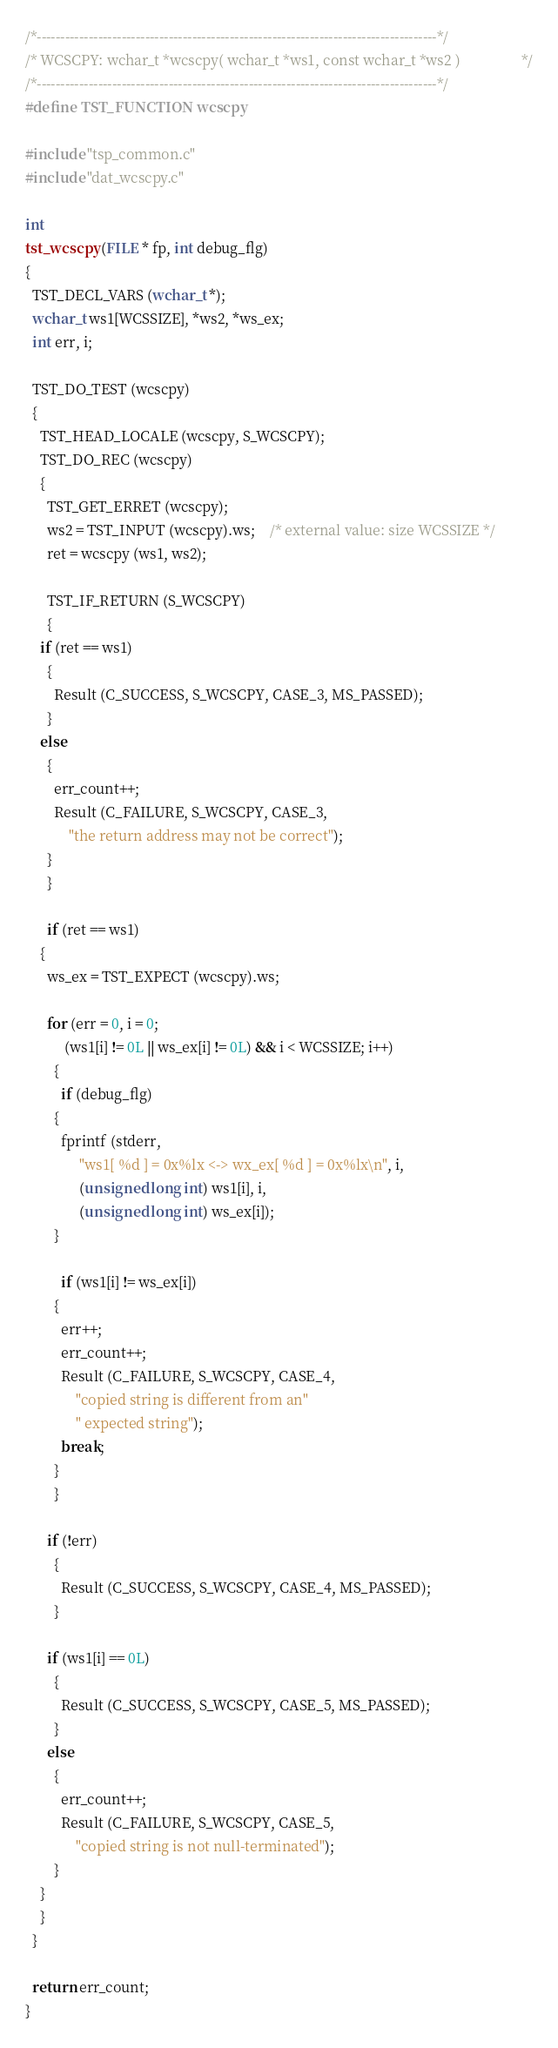<code> <loc_0><loc_0><loc_500><loc_500><_C_>/*-------------------------------------------------------------------------------------*/
/* WCSCPY: wchar_t *wcscpy( wchar_t *ws1, const wchar_t *ws2 )			       */
/*-------------------------------------------------------------------------------------*/
#define TST_FUNCTION wcscpy

#include "tsp_common.c"
#include "dat_wcscpy.c"

int
tst_wcscpy (FILE * fp, int debug_flg)
{
  TST_DECL_VARS (wchar_t *);
  wchar_t ws1[WCSSIZE], *ws2, *ws_ex;
  int err, i;

  TST_DO_TEST (wcscpy)
  {
    TST_HEAD_LOCALE (wcscpy, S_WCSCPY);
    TST_DO_REC (wcscpy)
    {
      TST_GET_ERRET (wcscpy);
      ws2 = TST_INPUT (wcscpy).ws;	/* external value: size WCSSIZE */
      ret = wcscpy (ws1, ws2);

      TST_IF_RETURN (S_WCSCPY)
      {
	if (ret == ws1)
	  {
	    Result (C_SUCCESS, S_WCSCPY, CASE_3, MS_PASSED);
	  }
	else
	  {
	    err_count++;
	    Result (C_FAILURE, S_WCSCPY, CASE_3,
		    "the return address may not be correct");
	  }
      }

      if (ret == ws1)
	{
	  ws_ex = TST_EXPECT (wcscpy).ws;

	  for (err = 0, i = 0;
	       (ws1[i] != 0L || ws_ex[i] != 0L) && i < WCSSIZE; i++)
	    {
	      if (debug_flg)
		{
		  fprintf (stderr,
			   "ws1[ %d ] = 0x%lx <-> wx_ex[ %d ] = 0x%lx\n", i,
			   (unsigned long int) ws1[i], i,
			   (unsigned long int) ws_ex[i]);
		}

	      if (ws1[i] != ws_ex[i])
		{
		  err++;
		  err_count++;
		  Result (C_FAILURE, S_WCSCPY, CASE_4,
			  "copied string is different from an"
			  " expected string");
		  break;
		}
	    }

	  if (!err)
	    {
	      Result (C_SUCCESS, S_WCSCPY, CASE_4, MS_PASSED);
	    }

	  if (ws1[i] == 0L)
	    {
	      Result (C_SUCCESS, S_WCSCPY, CASE_5, MS_PASSED);
	    }
	  else
	    {
	      err_count++;
	      Result (C_FAILURE, S_WCSCPY, CASE_5,
		      "copied string is not null-terminated");
	    }
	}
    }
  }

  return err_count;
}
</code> 